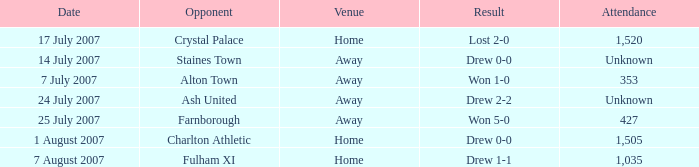Name the venue for staines town Away. 